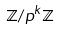Convert formula to latex. <formula><loc_0><loc_0><loc_500><loc_500>\mathbb { Z } / p ^ { k } \mathbb { Z }</formula> 